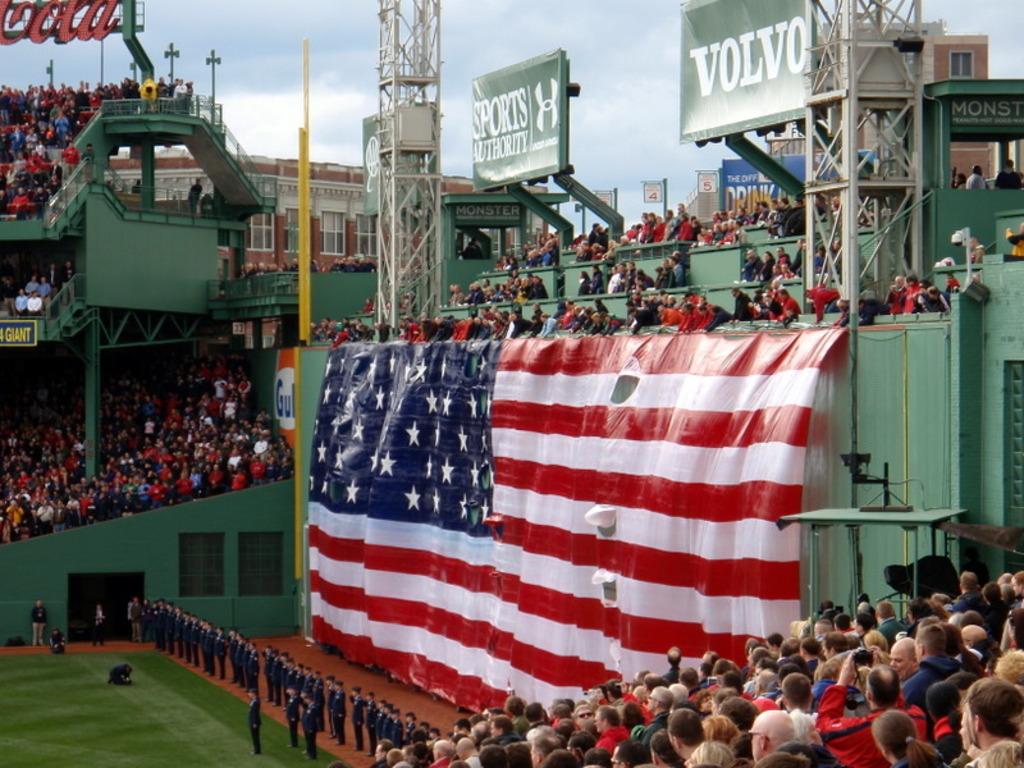What auto company is a sponsor?
Your response must be concise. Volvo. 